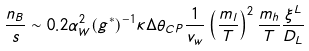Convert formula to latex. <formula><loc_0><loc_0><loc_500><loc_500>\frac { n _ { B } } { s } \sim 0 . 2 \alpha ^ { 2 } _ { W } ( g ^ { * } ) ^ { - 1 } \kappa \Delta \theta _ { C P } \frac { 1 } { v _ { w } } \left ( \frac { m _ { l } } { T } \right ) ^ { 2 } \frac { m _ { h } } { T } \frac { \xi ^ { L } } { D _ { L } }</formula> 